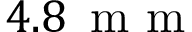Convert formula to latex. <formula><loc_0><loc_0><loc_500><loc_500>4 . 8 \, m m</formula> 